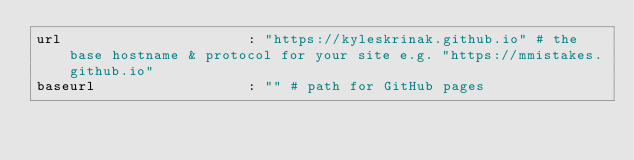<code> <loc_0><loc_0><loc_500><loc_500><_YAML_>url                      : "https://kyleskrinak.github.io" # the base hostname & protocol for your site e.g. "https://mmistakes.github.io"
baseurl                  : "" # path for GitHub pages
</code> 